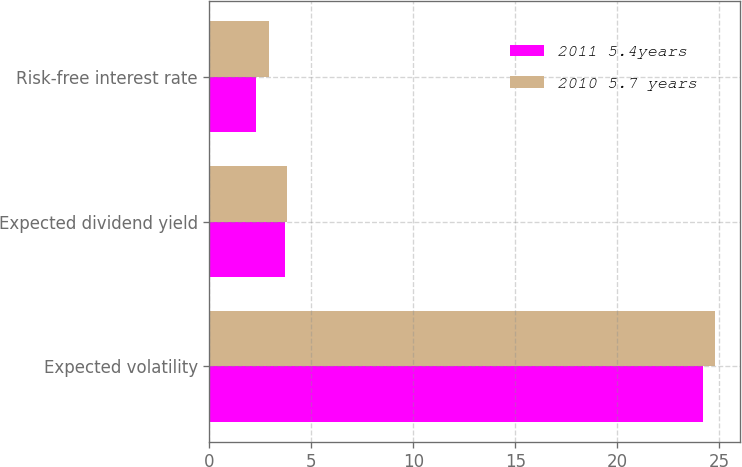Convert chart. <chart><loc_0><loc_0><loc_500><loc_500><stacked_bar_chart><ecel><fcel>Expected volatility<fcel>Expected dividend yield<fcel>Risk-free interest rate<nl><fcel>2011 5.4years<fcel>24.2<fcel>3.7<fcel>2.3<nl><fcel>2010 5.7 years<fcel>24.8<fcel>3.8<fcel>2.9<nl></chart> 